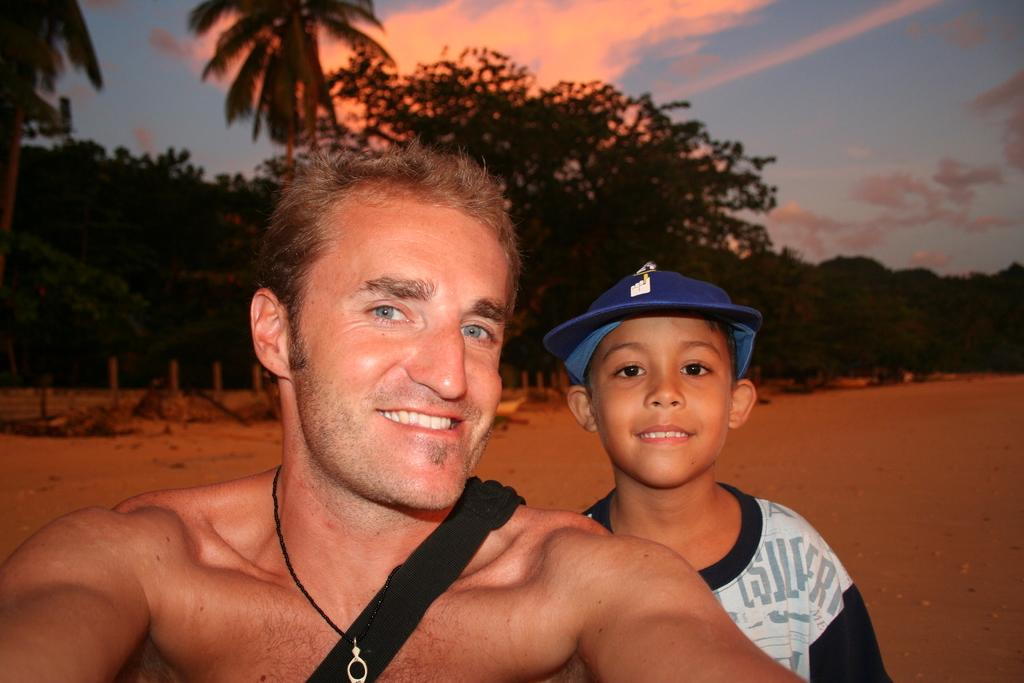Who is present in the image? There is a man and a kid in the image. What are the expressions on their faces? Both the man and the kid are smiling in the image. What is the boy wearing on his head? The boy is wearing a cap. What is the man carrying on his body? The man is wearing a bag. What type of terrain is visible in the image? There is sand visible in the image. What can be seen in the background of the image? There are trees and a clear sky in the background of the image. What type of plastic is being used to create steam in the image? There is no plastic or steam present in the image. What type of oven can be seen in the background of the image? There is no oven present in the image; only trees and a clear sky are visible in the background. 